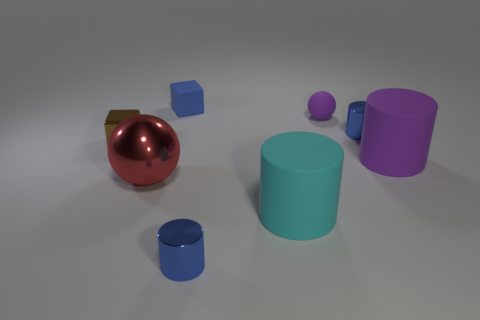Subtract all cyan rubber cylinders. How many cylinders are left? 3 Add 1 tiny purple spheres. How many objects exist? 9 Subtract all cyan cubes. How many blue cylinders are left? 2 Subtract 2 cylinders. How many cylinders are left? 2 Subtract all cyan cylinders. How many cylinders are left? 3 Subtract all cubes. How many objects are left? 6 Subtract all brown cylinders. Subtract all brown cubes. How many cylinders are left? 4 Add 1 brown shiny things. How many brown shiny things exist? 2 Subtract 0 brown cylinders. How many objects are left? 8 Subtract all big brown rubber cubes. Subtract all large matte things. How many objects are left? 6 